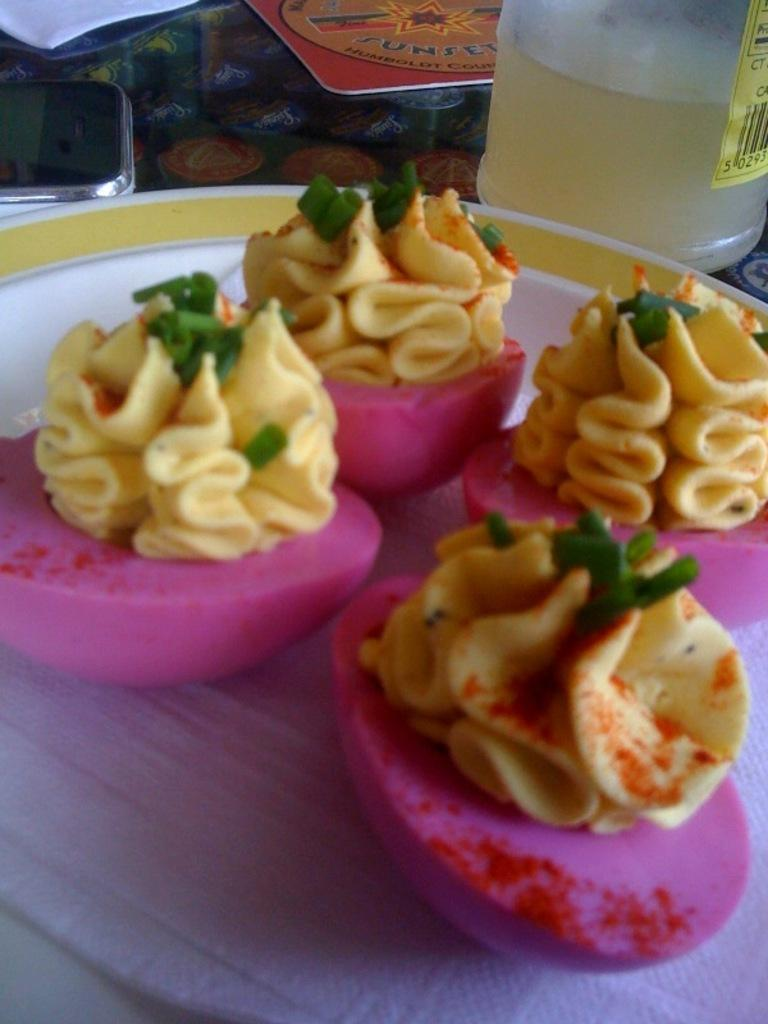What is on the plate that is visible in the image? There are food items on a plate in the image. Where is the plate located in the image? The plate is placed on a platform in the image. What can be seen in the background of the image? There is a mobile and some unspecified objects in the background of the image. What type of song is being played on the pear in the image? There is no pear or song present in the image. 